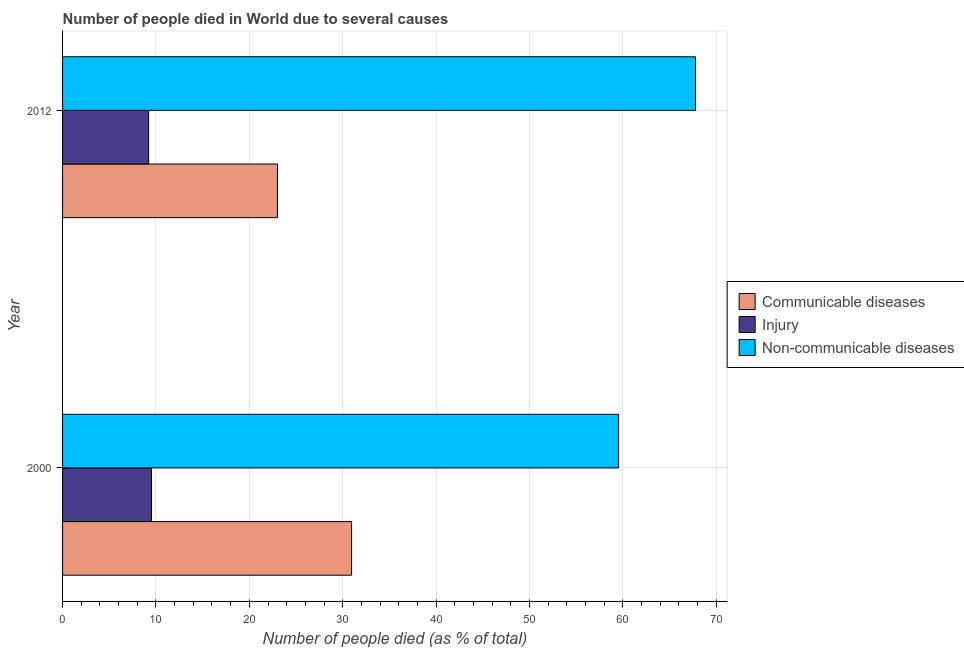Are the number of bars on each tick of the Y-axis equal?
Ensure brevity in your answer.  Yes. How many bars are there on the 1st tick from the top?
Ensure brevity in your answer.  3. How many bars are there on the 1st tick from the bottom?
Your answer should be very brief. 3. What is the label of the 1st group of bars from the top?
Keep it short and to the point. 2012. What is the number of people who dies of non-communicable diseases in 2000?
Your answer should be compact. 59.54. Across all years, what is the maximum number of people who died of injury?
Offer a terse response. 9.52. Across all years, what is the minimum number of people who died of injury?
Your answer should be compact. 9.22. What is the total number of people who dies of non-communicable diseases in the graph?
Your answer should be very brief. 127.31. What is the difference between the number of people who died of communicable diseases in 2000 and the number of people who died of injury in 2012?
Keep it short and to the point. 21.73. What is the average number of people who died of communicable diseases per year?
Keep it short and to the point. 26.98. In the year 2000, what is the difference between the number of people who died of injury and number of people who dies of non-communicable diseases?
Keep it short and to the point. -50.02. What is the ratio of the number of people who dies of non-communicable diseases in 2000 to that in 2012?
Your response must be concise. 0.88. Is the number of people who died of injury in 2000 less than that in 2012?
Keep it short and to the point. No. Is the difference between the number of people who dies of non-communicable diseases in 2000 and 2012 greater than the difference between the number of people who died of communicable diseases in 2000 and 2012?
Ensure brevity in your answer.  No. What does the 3rd bar from the top in 2012 represents?
Your response must be concise. Communicable diseases. What does the 2nd bar from the bottom in 2012 represents?
Ensure brevity in your answer.  Injury. Is it the case that in every year, the sum of the number of people who died of communicable diseases and number of people who died of injury is greater than the number of people who dies of non-communicable diseases?
Keep it short and to the point. No. How many bars are there?
Provide a short and direct response. 6. How many years are there in the graph?
Your response must be concise. 2. What is the difference between two consecutive major ticks on the X-axis?
Ensure brevity in your answer.  10. Are the values on the major ticks of X-axis written in scientific E-notation?
Ensure brevity in your answer.  No. Does the graph contain any zero values?
Keep it short and to the point. No. Does the graph contain grids?
Your response must be concise. Yes. Where does the legend appear in the graph?
Your answer should be compact. Center right. What is the title of the graph?
Offer a very short reply. Number of people died in World due to several causes. Does "Ages 0-14" appear as one of the legend labels in the graph?
Your answer should be compact. No. What is the label or title of the X-axis?
Make the answer very short. Number of people died (as % of total). What is the Number of people died (as % of total) in Communicable diseases in 2000?
Offer a terse response. 30.95. What is the Number of people died (as % of total) of Injury in 2000?
Your answer should be compact. 9.52. What is the Number of people died (as % of total) in Non-communicable diseases in 2000?
Provide a short and direct response. 59.54. What is the Number of people died (as % of total) in Communicable diseases in 2012?
Your answer should be compact. 23.01. What is the Number of people died (as % of total) of Injury in 2012?
Offer a very short reply. 9.22. What is the Number of people died (as % of total) of Non-communicable diseases in 2012?
Keep it short and to the point. 67.77. Across all years, what is the maximum Number of people died (as % of total) in Communicable diseases?
Your answer should be compact. 30.95. Across all years, what is the maximum Number of people died (as % of total) of Injury?
Your answer should be very brief. 9.52. Across all years, what is the maximum Number of people died (as % of total) in Non-communicable diseases?
Your response must be concise. 67.77. Across all years, what is the minimum Number of people died (as % of total) of Communicable diseases?
Offer a terse response. 23.01. Across all years, what is the minimum Number of people died (as % of total) in Injury?
Offer a terse response. 9.22. Across all years, what is the minimum Number of people died (as % of total) of Non-communicable diseases?
Your answer should be very brief. 59.54. What is the total Number of people died (as % of total) of Communicable diseases in the graph?
Offer a very short reply. 53.96. What is the total Number of people died (as % of total) of Injury in the graph?
Provide a short and direct response. 18.74. What is the total Number of people died (as % of total) of Non-communicable diseases in the graph?
Offer a very short reply. 127.31. What is the difference between the Number of people died (as % of total) in Communicable diseases in 2000 and that in 2012?
Your response must be concise. 7.94. What is the difference between the Number of people died (as % of total) in Injury in 2000 and that in 2012?
Keep it short and to the point. 0.3. What is the difference between the Number of people died (as % of total) of Non-communicable diseases in 2000 and that in 2012?
Offer a terse response. -8.24. What is the difference between the Number of people died (as % of total) in Communicable diseases in 2000 and the Number of people died (as % of total) in Injury in 2012?
Provide a succinct answer. 21.73. What is the difference between the Number of people died (as % of total) of Communicable diseases in 2000 and the Number of people died (as % of total) of Non-communicable diseases in 2012?
Make the answer very short. -36.82. What is the difference between the Number of people died (as % of total) in Injury in 2000 and the Number of people died (as % of total) in Non-communicable diseases in 2012?
Provide a short and direct response. -58.25. What is the average Number of people died (as % of total) of Communicable diseases per year?
Keep it short and to the point. 26.98. What is the average Number of people died (as % of total) of Injury per year?
Keep it short and to the point. 9.37. What is the average Number of people died (as % of total) of Non-communicable diseases per year?
Provide a short and direct response. 63.65. In the year 2000, what is the difference between the Number of people died (as % of total) in Communicable diseases and Number of people died (as % of total) in Injury?
Offer a very short reply. 21.43. In the year 2000, what is the difference between the Number of people died (as % of total) of Communicable diseases and Number of people died (as % of total) of Non-communicable diseases?
Offer a very short reply. -28.59. In the year 2000, what is the difference between the Number of people died (as % of total) in Injury and Number of people died (as % of total) in Non-communicable diseases?
Your answer should be compact. -50.02. In the year 2012, what is the difference between the Number of people died (as % of total) in Communicable diseases and Number of people died (as % of total) in Injury?
Give a very brief answer. 13.79. In the year 2012, what is the difference between the Number of people died (as % of total) in Communicable diseases and Number of people died (as % of total) in Non-communicable diseases?
Ensure brevity in your answer.  -44.76. In the year 2012, what is the difference between the Number of people died (as % of total) of Injury and Number of people died (as % of total) of Non-communicable diseases?
Ensure brevity in your answer.  -58.55. What is the ratio of the Number of people died (as % of total) in Communicable diseases in 2000 to that in 2012?
Your answer should be very brief. 1.35. What is the ratio of the Number of people died (as % of total) of Injury in 2000 to that in 2012?
Keep it short and to the point. 1.03. What is the ratio of the Number of people died (as % of total) in Non-communicable diseases in 2000 to that in 2012?
Give a very brief answer. 0.88. What is the difference between the highest and the second highest Number of people died (as % of total) in Communicable diseases?
Offer a very short reply. 7.94. What is the difference between the highest and the second highest Number of people died (as % of total) of Injury?
Keep it short and to the point. 0.3. What is the difference between the highest and the second highest Number of people died (as % of total) in Non-communicable diseases?
Offer a terse response. 8.24. What is the difference between the highest and the lowest Number of people died (as % of total) of Communicable diseases?
Your response must be concise. 7.94. What is the difference between the highest and the lowest Number of people died (as % of total) of Injury?
Offer a very short reply. 0.3. What is the difference between the highest and the lowest Number of people died (as % of total) in Non-communicable diseases?
Give a very brief answer. 8.24. 